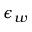Convert formula to latex. <formula><loc_0><loc_0><loc_500><loc_500>\epsilon _ { w }</formula> 